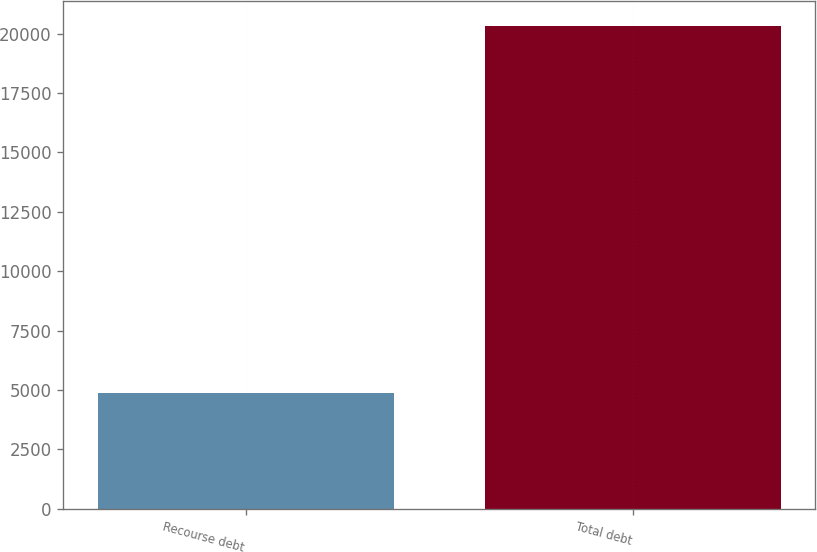<chart> <loc_0><loc_0><loc_500><loc_500><bar_chart><fcel>Recourse debt<fcel>Total debt<nl><fcel>4868<fcel>20339<nl></chart> 